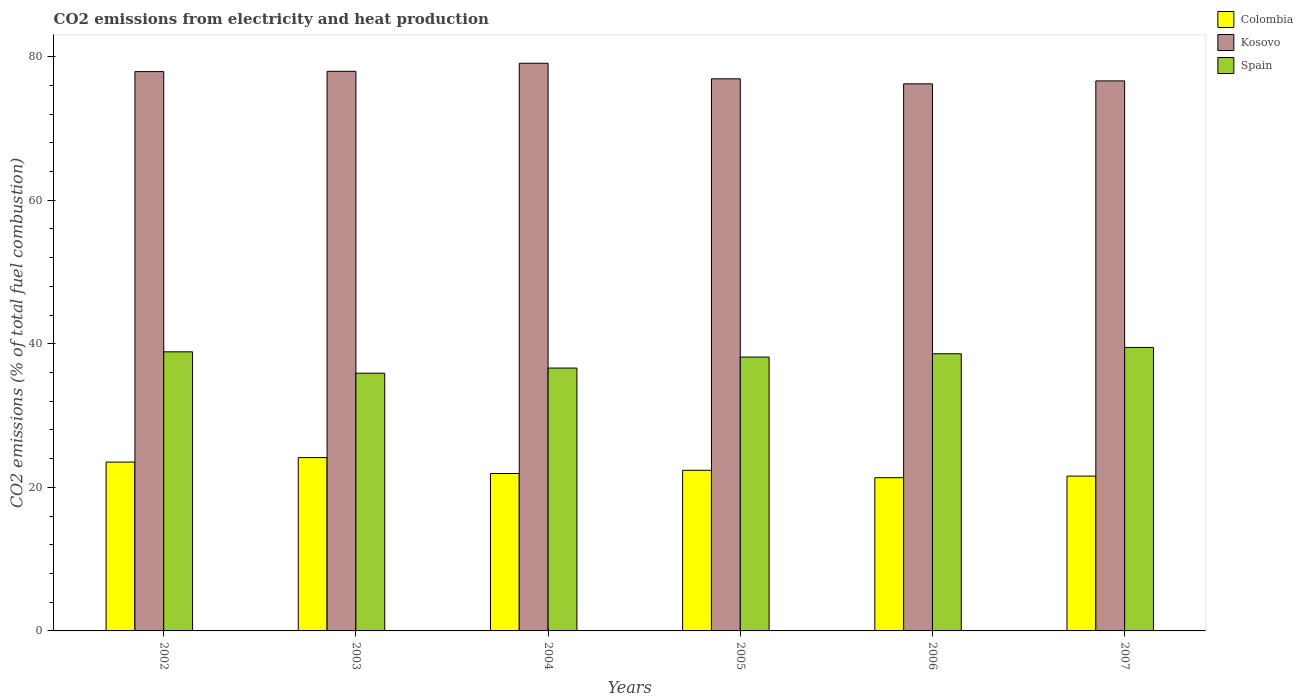Are the number of bars per tick equal to the number of legend labels?
Your answer should be very brief. Yes. Are the number of bars on each tick of the X-axis equal?
Provide a succinct answer. Yes. How many bars are there on the 6th tick from the left?
Your answer should be compact. 3. How many bars are there on the 2nd tick from the right?
Ensure brevity in your answer.  3. What is the label of the 5th group of bars from the left?
Your answer should be compact. 2006. What is the amount of CO2 emitted in Kosovo in 2002?
Make the answer very short. 77.92. Across all years, what is the maximum amount of CO2 emitted in Kosovo?
Make the answer very short. 79.08. Across all years, what is the minimum amount of CO2 emitted in Colombia?
Provide a short and direct response. 21.35. What is the total amount of CO2 emitted in Spain in the graph?
Ensure brevity in your answer.  227.66. What is the difference between the amount of CO2 emitted in Spain in 2002 and that in 2003?
Offer a terse response. 2.98. What is the difference between the amount of CO2 emitted in Spain in 2003 and the amount of CO2 emitted in Kosovo in 2005?
Your answer should be compact. -41.01. What is the average amount of CO2 emitted in Kosovo per year?
Your answer should be compact. 77.45. In the year 2006, what is the difference between the amount of CO2 emitted in Colombia and amount of CO2 emitted in Spain?
Offer a terse response. -17.27. In how many years, is the amount of CO2 emitted in Kosovo greater than 8 %?
Make the answer very short. 6. What is the ratio of the amount of CO2 emitted in Spain in 2003 to that in 2005?
Offer a very short reply. 0.94. Is the amount of CO2 emitted in Colombia in 2004 less than that in 2006?
Provide a succinct answer. No. What is the difference between the highest and the second highest amount of CO2 emitted in Colombia?
Give a very brief answer. 0.62. What is the difference between the highest and the lowest amount of CO2 emitted in Kosovo?
Make the answer very short. 2.87. In how many years, is the amount of CO2 emitted in Colombia greater than the average amount of CO2 emitted in Colombia taken over all years?
Give a very brief answer. 2. Is it the case that in every year, the sum of the amount of CO2 emitted in Kosovo and amount of CO2 emitted in Colombia is greater than the amount of CO2 emitted in Spain?
Provide a succinct answer. Yes. Are all the bars in the graph horizontal?
Give a very brief answer. No. What is the difference between two consecutive major ticks on the Y-axis?
Your response must be concise. 20. Are the values on the major ticks of Y-axis written in scientific E-notation?
Your answer should be very brief. No. Does the graph contain any zero values?
Offer a terse response. No. Does the graph contain grids?
Make the answer very short. No. How many legend labels are there?
Make the answer very short. 3. What is the title of the graph?
Ensure brevity in your answer.  CO2 emissions from electricity and heat production. Does "Luxembourg" appear as one of the legend labels in the graph?
Offer a very short reply. No. What is the label or title of the X-axis?
Provide a short and direct response. Years. What is the label or title of the Y-axis?
Your answer should be compact. CO2 emissions (% of total fuel combustion). What is the CO2 emissions (% of total fuel combustion) of Colombia in 2002?
Your answer should be very brief. 23.52. What is the CO2 emissions (% of total fuel combustion) in Kosovo in 2002?
Your answer should be compact. 77.92. What is the CO2 emissions (% of total fuel combustion) of Spain in 2002?
Keep it short and to the point. 38.88. What is the CO2 emissions (% of total fuel combustion) of Colombia in 2003?
Your response must be concise. 24.15. What is the CO2 emissions (% of total fuel combustion) in Kosovo in 2003?
Provide a short and direct response. 77.96. What is the CO2 emissions (% of total fuel combustion) in Spain in 2003?
Your response must be concise. 35.9. What is the CO2 emissions (% of total fuel combustion) of Colombia in 2004?
Your answer should be very brief. 21.92. What is the CO2 emissions (% of total fuel combustion) of Kosovo in 2004?
Provide a short and direct response. 79.08. What is the CO2 emissions (% of total fuel combustion) in Spain in 2004?
Your answer should be very brief. 36.62. What is the CO2 emissions (% of total fuel combustion) in Colombia in 2005?
Offer a terse response. 22.38. What is the CO2 emissions (% of total fuel combustion) in Kosovo in 2005?
Your response must be concise. 76.91. What is the CO2 emissions (% of total fuel combustion) of Spain in 2005?
Ensure brevity in your answer.  38.15. What is the CO2 emissions (% of total fuel combustion) in Colombia in 2006?
Provide a succinct answer. 21.35. What is the CO2 emissions (% of total fuel combustion) of Kosovo in 2006?
Give a very brief answer. 76.21. What is the CO2 emissions (% of total fuel combustion) in Spain in 2006?
Offer a very short reply. 38.61. What is the CO2 emissions (% of total fuel combustion) in Colombia in 2007?
Make the answer very short. 21.57. What is the CO2 emissions (% of total fuel combustion) in Kosovo in 2007?
Your answer should be very brief. 76.62. What is the CO2 emissions (% of total fuel combustion) in Spain in 2007?
Ensure brevity in your answer.  39.49. Across all years, what is the maximum CO2 emissions (% of total fuel combustion) in Colombia?
Ensure brevity in your answer.  24.15. Across all years, what is the maximum CO2 emissions (% of total fuel combustion) of Kosovo?
Provide a short and direct response. 79.08. Across all years, what is the maximum CO2 emissions (% of total fuel combustion) of Spain?
Give a very brief answer. 39.49. Across all years, what is the minimum CO2 emissions (% of total fuel combustion) in Colombia?
Make the answer very short. 21.35. Across all years, what is the minimum CO2 emissions (% of total fuel combustion) in Kosovo?
Offer a terse response. 76.21. Across all years, what is the minimum CO2 emissions (% of total fuel combustion) of Spain?
Your answer should be compact. 35.9. What is the total CO2 emissions (% of total fuel combustion) of Colombia in the graph?
Provide a short and direct response. 134.88. What is the total CO2 emissions (% of total fuel combustion) in Kosovo in the graph?
Give a very brief answer. 464.71. What is the total CO2 emissions (% of total fuel combustion) in Spain in the graph?
Keep it short and to the point. 227.66. What is the difference between the CO2 emissions (% of total fuel combustion) of Colombia in 2002 and that in 2003?
Your response must be concise. -0.62. What is the difference between the CO2 emissions (% of total fuel combustion) of Kosovo in 2002 and that in 2003?
Your answer should be very brief. -0.04. What is the difference between the CO2 emissions (% of total fuel combustion) of Spain in 2002 and that in 2003?
Your answer should be compact. 2.98. What is the difference between the CO2 emissions (% of total fuel combustion) of Colombia in 2002 and that in 2004?
Provide a short and direct response. 1.6. What is the difference between the CO2 emissions (% of total fuel combustion) in Kosovo in 2002 and that in 2004?
Provide a short and direct response. -1.16. What is the difference between the CO2 emissions (% of total fuel combustion) in Spain in 2002 and that in 2004?
Keep it short and to the point. 2.26. What is the difference between the CO2 emissions (% of total fuel combustion) of Colombia in 2002 and that in 2005?
Give a very brief answer. 1.15. What is the difference between the CO2 emissions (% of total fuel combustion) in Spain in 2002 and that in 2005?
Provide a short and direct response. 0.73. What is the difference between the CO2 emissions (% of total fuel combustion) in Colombia in 2002 and that in 2006?
Your answer should be compact. 2.18. What is the difference between the CO2 emissions (% of total fuel combustion) in Kosovo in 2002 and that in 2006?
Your answer should be very brief. 1.71. What is the difference between the CO2 emissions (% of total fuel combustion) of Spain in 2002 and that in 2006?
Give a very brief answer. 0.27. What is the difference between the CO2 emissions (% of total fuel combustion) of Colombia in 2002 and that in 2007?
Your answer should be very brief. 1.96. What is the difference between the CO2 emissions (% of total fuel combustion) of Kosovo in 2002 and that in 2007?
Your answer should be compact. 1.29. What is the difference between the CO2 emissions (% of total fuel combustion) in Spain in 2002 and that in 2007?
Ensure brevity in your answer.  -0.61. What is the difference between the CO2 emissions (% of total fuel combustion) in Colombia in 2003 and that in 2004?
Make the answer very short. 2.22. What is the difference between the CO2 emissions (% of total fuel combustion) of Kosovo in 2003 and that in 2004?
Make the answer very short. -1.12. What is the difference between the CO2 emissions (% of total fuel combustion) in Spain in 2003 and that in 2004?
Provide a succinct answer. -0.72. What is the difference between the CO2 emissions (% of total fuel combustion) in Colombia in 2003 and that in 2005?
Offer a very short reply. 1.77. What is the difference between the CO2 emissions (% of total fuel combustion) in Kosovo in 2003 and that in 2005?
Your answer should be very brief. 1.05. What is the difference between the CO2 emissions (% of total fuel combustion) of Spain in 2003 and that in 2005?
Ensure brevity in your answer.  -2.25. What is the difference between the CO2 emissions (% of total fuel combustion) in Colombia in 2003 and that in 2006?
Your answer should be very brief. 2.8. What is the difference between the CO2 emissions (% of total fuel combustion) in Kosovo in 2003 and that in 2006?
Provide a succinct answer. 1.75. What is the difference between the CO2 emissions (% of total fuel combustion) of Spain in 2003 and that in 2006?
Ensure brevity in your answer.  -2.71. What is the difference between the CO2 emissions (% of total fuel combustion) of Colombia in 2003 and that in 2007?
Your response must be concise. 2.58. What is the difference between the CO2 emissions (% of total fuel combustion) of Kosovo in 2003 and that in 2007?
Make the answer very short. 1.34. What is the difference between the CO2 emissions (% of total fuel combustion) of Spain in 2003 and that in 2007?
Ensure brevity in your answer.  -3.59. What is the difference between the CO2 emissions (% of total fuel combustion) of Colombia in 2004 and that in 2005?
Offer a very short reply. -0.45. What is the difference between the CO2 emissions (% of total fuel combustion) of Kosovo in 2004 and that in 2005?
Ensure brevity in your answer.  2.17. What is the difference between the CO2 emissions (% of total fuel combustion) of Spain in 2004 and that in 2005?
Provide a short and direct response. -1.53. What is the difference between the CO2 emissions (% of total fuel combustion) of Colombia in 2004 and that in 2006?
Your answer should be very brief. 0.58. What is the difference between the CO2 emissions (% of total fuel combustion) in Kosovo in 2004 and that in 2006?
Your answer should be compact. 2.87. What is the difference between the CO2 emissions (% of total fuel combustion) in Spain in 2004 and that in 2006?
Make the answer very short. -1.99. What is the difference between the CO2 emissions (% of total fuel combustion) in Colombia in 2004 and that in 2007?
Keep it short and to the point. 0.36. What is the difference between the CO2 emissions (% of total fuel combustion) in Kosovo in 2004 and that in 2007?
Offer a terse response. 2.46. What is the difference between the CO2 emissions (% of total fuel combustion) of Spain in 2004 and that in 2007?
Keep it short and to the point. -2.87. What is the difference between the CO2 emissions (% of total fuel combustion) of Colombia in 2005 and that in 2006?
Provide a succinct answer. 1.03. What is the difference between the CO2 emissions (% of total fuel combustion) of Kosovo in 2005 and that in 2006?
Keep it short and to the point. 0.7. What is the difference between the CO2 emissions (% of total fuel combustion) in Spain in 2005 and that in 2006?
Make the answer very short. -0.46. What is the difference between the CO2 emissions (% of total fuel combustion) of Colombia in 2005 and that in 2007?
Provide a short and direct response. 0.81. What is the difference between the CO2 emissions (% of total fuel combustion) of Kosovo in 2005 and that in 2007?
Your answer should be very brief. 0.29. What is the difference between the CO2 emissions (% of total fuel combustion) of Spain in 2005 and that in 2007?
Give a very brief answer. -1.34. What is the difference between the CO2 emissions (% of total fuel combustion) in Colombia in 2006 and that in 2007?
Your answer should be compact. -0.22. What is the difference between the CO2 emissions (% of total fuel combustion) of Kosovo in 2006 and that in 2007?
Provide a short and direct response. -0.41. What is the difference between the CO2 emissions (% of total fuel combustion) of Spain in 2006 and that in 2007?
Provide a short and direct response. -0.88. What is the difference between the CO2 emissions (% of total fuel combustion) of Colombia in 2002 and the CO2 emissions (% of total fuel combustion) of Kosovo in 2003?
Your answer should be compact. -54.44. What is the difference between the CO2 emissions (% of total fuel combustion) of Colombia in 2002 and the CO2 emissions (% of total fuel combustion) of Spain in 2003?
Make the answer very short. -12.38. What is the difference between the CO2 emissions (% of total fuel combustion) in Kosovo in 2002 and the CO2 emissions (% of total fuel combustion) in Spain in 2003?
Give a very brief answer. 42.02. What is the difference between the CO2 emissions (% of total fuel combustion) of Colombia in 2002 and the CO2 emissions (% of total fuel combustion) of Kosovo in 2004?
Keep it short and to the point. -55.56. What is the difference between the CO2 emissions (% of total fuel combustion) of Colombia in 2002 and the CO2 emissions (% of total fuel combustion) of Spain in 2004?
Keep it short and to the point. -13.1. What is the difference between the CO2 emissions (% of total fuel combustion) of Kosovo in 2002 and the CO2 emissions (% of total fuel combustion) of Spain in 2004?
Provide a short and direct response. 41.3. What is the difference between the CO2 emissions (% of total fuel combustion) in Colombia in 2002 and the CO2 emissions (% of total fuel combustion) in Kosovo in 2005?
Ensure brevity in your answer.  -53.39. What is the difference between the CO2 emissions (% of total fuel combustion) in Colombia in 2002 and the CO2 emissions (% of total fuel combustion) in Spain in 2005?
Provide a short and direct response. -14.63. What is the difference between the CO2 emissions (% of total fuel combustion) in Kosovo in 2002 and the CO2 emissions (% of total fuel combustion) in Spain in 2005?
Your response must be concise. 39.77. What is the difference between the CO2 emissions (% of total fuel combustion) in Colombia in 2002 and the CO2 emissions (% of total fuel combustion) in Kosovo in 2006?
Provide a short and direct response. -52.69. What is the difference between the CO2 emissions (% of total fuel combustion) in Colombia in 2002 and the CO2 emissions (% of total fuel combustion) in Spain in 2006?
Provide a succinct answer. -15.09. What is the difference between the CO2 emissions (% of total fuel combustion) in Kosovo in 2002 and the CO2 emissions (% of total fuel combustion) in Spain in 2006?
Your answer should be very brief. 39.31. What is the difference between the CO2 emissions (% of total fuel combustion) in Colombia in 2002 and the CO2 emissions (% of total fuel combustion) in Kosovo in 2007?
Your answer should be compact. -53.1. What is the difference between the CO2 emissions (% of total fuel combustion) of Colombia in 2002 and the CO2 emissions (% of total fuel combustion) of Spain in 2007?
Make the answer very short. -15.97. What is the difference between the CO2 emissions (% of total fuel combustion) of Kosovo in 2002 and the CO2 emissions (% of total fuel combustion) of Spain in 2007?
Offer a very short reply. 38.43. What is the difference between the CO2 emissions (% of total fuel combustion) in Colombia in 2003 and the CO2 emissions (% of total fuel combustion) in Kosovo in 2004?
Your answer should be compact. -54.93. What is the difference between the CO2 emissions (% of total fuel combustion) of Colombia in 2003 and the CO2 emissions (% of total fuel combustion) of Spain in 2004?
Keep it short and to the point. -12.47. What is the difference between the CO2 emissions (% of total fuel combustion) of Kosovo in 2003 and the CO2 emissions (% of total fuel combustion) of Spain in 2004?
Make the answer very short. 41.34. What is the difference between the CO2 emissions (% of total fuel combustion) of Colombia in 2003 and the CO2 emissions (% of total fuel combustion) of Kosovo in 2005?
Your answer should be very brief. -52.76. What is the difference between the CO2 emissions (% of total fuel combustion) of Colombia in 2003 and the CO2 emissions (% of total fuel combustion) of Spain in 2005?
Ensure brevity in your answer.  -14.01. What is the difference between the CO2 emissions (% of total fuel combustion) of Kosovo in 2003 and the CO2 emissions (% of total fuel combustion) of Spain in 2005?
Your answer should be very brief. 39.81. What is the difference between the CO2 emissions (% of total fuel combustion) in Colombia in 2003 and the CO2 emissions (% of total fuel combustion) in Kosovo in 2006?
Your answer should be very brief. -52.07. What is the difference between the CO2 emissions (% of total fuel combustion) in Colombia in 2003 and the CO2 emissions (% of total fuel combustion) in Spain in 2006?
Offer a very short reply. -14.46. What is the difference between the CO2 emissions (% of total fuel combustion) in Kosovo in 2003 and the CO2 emissions (% of total fuel combustion) in Spain in 2006?
Ensure brevity in your answer.  39.35. What is the difference between the CO2 emissions (% of total fuel combustion) in Colombia in 2003 and the CO2 emissions (% of total fuel combustion) in Kosovo in 2007?
Provide a short and direct response. -52.48. What is the difference between the CO2 emissions (% of total fuel combustion) in Colombia in 2003 and the CO2 emissions (% of total fuel combustion) in Spain in 2007?
Ensure brevity in your answer.  -15.35. What is the difference between the CO2 emissions (% of total fuel combustion) of Kosovo in 2003 and the CO2 emissions (% of total fuel combustion) of Spain in 2007?
Your response must be concise. 38.47. What is the difference between the CO2 emissions (% of total fuel combustion) of Colombia in 2004 and the CO2 emissions (% of total fuel combustion) of Kosovo in 2005?
Offer a very short reply. -54.99. What is the difference between the CO2 emissions (% of total fuel combustion) in Colombia in 2004 and the CO2 emissions (% of total fuel combustion) in Spain in 2005?
Give a very brief answer. -16.23. What is the difference between the CO2 emissions (% of total fuel combustion) of Kosovo in 2004 and the CO2 emissions (% of total fuel combustion) of Spain in 2005?
Offer a very short reply. 40.93. What is the difference between the CO2 emissions (% of total fuel combustion) of Colombia in 2004 and the CO2 emissions (% of total fuel combustion) of Kosovo in 2006?
Your response must be concise. -54.29. What is the difference between the CO2 emissions (% of total fuel combustion) of Colombia in 2004 and the CO2 emissions (% of total fuel combustion) of Spain in 2006?
Ensure brevity in your answer.  -16.69. What is the difference between the CO2 emissions (% of total fuel combustion) in Kosovo in 2004 and the CO2 emissions (% of total fuel combustion) in Spain in 2006?
Ensure brevity in your answer.  40.47. What is the difference between the CO2 emissions (% of total fuel combustion) of Colombia in 2004 and the CO2 emissions (% of total fuel combustion) of Kosovo in 2007?
Your answer should be compact. -54.7. What is the difference between the CO2 emissions (% of total fuel combustion) in Colombia in 2004 and the CO2 emissions (% of total fuel combustion) in Spain in 2007?
Make the answer very short. -17.57. What is the difference between the CO2 emissions (% of total fuel combustion) of Kosovo in 2004 and the CO2 emissions (% of total fuel combustion) of Spain in 2007?
Provide a short and direct response. 39.59. What is the difference between the CO2 emissions (% of total fuel combustion) in Colombia in 2005 and the CO2 emissions (% of total fuel combustion) in Kosovo in 2006?
Provide a succinct answer. -53.83. What is the difference between the CO2 emissions (% of total fuel combustion) in Colombia in 2005 and the CO2 emissions (% of total fuel combustion) in Spain in 2006?
Offer a very short reply. -16.23. What is the difference between the CO2 emissions (% of total fuel combustion) of Kosovo in 2005 and the CO2 emissions (% of total fuel combustion) of Spain in 2006?
Your response must be concise. 38.3. What is the difference between the CO2 emissions (% of total fuel combustion) of Colombia in 2005 and the CO2 emissions (% of total fuel combustion) of Kosovo in 2007?
Provide a short and direct response. -54.25. What is the difference between the CO2 emissions (% of total fuel combustion) of Colombia in 2005 and the CO2 emissions (% of total fuel combustion) of Spain in 2007?
Provide a succinct answer. -17.12. What is the difference between the CO2 emissions (% of total fuel combustion) in Kosovo in 2005 and the CO2 emissions (% of total fuel combustion) in Spain in 2007?
Your answer should be compact. 37.42. What is the difference between the CO2 emissions (% of total fuel combustion) in Colombia in 2006 and the CO2 emissions (% of total fuel combustion) in Kosovo in 2007?
Offer a terse response. -55.28. What is the difference between the CO2 emissions (% of total fuel combustion) in Colombia in 2006 and the CO2 emissions (% of total fuel combustion) in Spain in 2007?
Offer a very short reply. -18.15. What is the difference between the CO2 emissions (% of total fuel combustion) in Kosovo in 2006 and the CO2 emissions (% of total fuel combustion) in Spain in 2007?
Provide a short and direct response. 36.72. What is the average CO2 emissions (% of total fuel combustion) of Colombia per year?
Make the answer very short. 22.48. What is the average CO2 emissions (% of total fuel combustion) in Kosovo per year?
Offer a very short reply. 77.45. What is the average CO2 emissions (% of total fuel combustion) in Spain per year?
Offer a terse response. 37.94. In the year 2002, what is the difference between the CO2 emissions (% of total fuel combustion) of Colombia and CO2 emissions (% of total fuel combustion) of Kosovo?
Your response must be concise. -54.39. In the year 2002, what is the difference between the CO2 emissions (% of total fuel combustion) in Colombia and CO2 emissions (% of total fuel combustion) in Spain?
Provide a short and direct response. -15.36. In the year 2002, what is the difference between the CO2 emissions (% of total fuel combustion) in Kosovo and CO2 emissions (% of total fuel combustion) in Spain?
Ensure brevity in your answer.  39.04. In the year 2003, what is the difference between the CO2 emissions (% of total fuel combustion) in Colombia and CO2 emissions (% of total fuel combustion) in Kosovo?
Ensure brevity in your answer.  -53.81. In the year 2003, what is the difference between the CO2 emissions (% of total fuel combustion) in Colombia and CO2 emissions (% of total fuel combustion) in Spain?
Provide a short and direct response. -11.75. In the year 2003, what is the difference between the CO2 emissions (% of total fuel combustion) in Kosovo and CO2 emissions (% of total fuel combustion) in Spain?
Ensure brevity in your answer.  42.06. In the year 2004, what is the difference between the CO2 emissions (% of total fuel combustion) of Colombia and CO2 emissions (% of total fuel combustion) of Kosovo?
Provide a short and direct response. -57.16. In the year 2004, what is the difference between the CO2 emissions (% of total fuel combustion) of Colombia and CO2 emissions (% of total fuel combustion) of Spain?
Provide a succinct answer. -14.69. In the year 2004, what is the difference between the CO2 emissions (% of total fuel combustion) in Kosovo and CO2 emissions (% of total fuel combustion) in Spain?
Provide a short and direct response. 42.46. In the year 2005, what is the difference between the CO2 emissions (% of total fuel combustion) in Colombia and CO2 emissions (% of total fuel combustion) in Kosovo?
Offer a very short reply. -54.53. In the year 2005, what is the difference between the CO2 emissions (% of total fuel combustion) in Colombia and CO2 emissions (% of total fuel combustion) in Spain?
Your answer should be very brief. -15.78. In the year 2005, what is the difference between the CO2 emissions (% of total fuel combustion) of Kosovo and CO2 emissions (% of total fuel combustion) of Spain?
Provide a succinct answer. 38.76. In the year 2006, what is the difference between the CO2 emissions (% of total fuel combustion) in Colombia and CO2 emissions (% of total fuel combustion) in Kosovo?
Ensure brevity in your answer.  -54.87. In the year 2006, what is the difference between the CO2 emissions (% of total fuel combustion) of Colombia and CO2 emissions (% of total fuel combustion) of Spain?
Your response must be concise. -17.27. In the year 2006, what is the difference between the CO2 emissions (% of total fuel combustion) in Kosovo and CO2 emissions (% of total fuel combustion) in Spain?
Give a very brief answer. 37.6. In the year 2007, what is the difference between the CO2 emissions (% of total fuel combustion) of Colombia and CO2 emissions (% of total fuel combustion) of Kosovo?
Your answer should be compact. -55.06. In the year 2007, what is the difference between the CO2 emissions (% of total fuel combustion) in Colombia and CO2 emissions (% of total fuel combustion) in Spain?
Offer a very short reply. -17.92. In the year 2007, what is the difference between the CO2 emissions (% of total fuel combustion) in Kosovo and CO2 emissions (% of total fuel combustion) in Spain?
Your answer should be very brief. 37.13. What is the ratio of the CO2 emissions (% of total fuel combustion) of Colombia in 2002 to that in 2003?
Keep it short and to the point. 0.97. What is the ratio of the CO2 emissions (% of total fuel combustion) in Spain in 2002 to that in 2003?
Offer a terse response. 1.08. What is the ratio of the CO2 emissions (% of total fuel combustion) of Colombia in 2002 to that in 2004?
Make the answer very short. 1.07. What is the ratio of the CO2 emissions (% of total fuel combustion) of Kosovo in 2002 to that in 2004?
Your response must be concise. 0.99. What is the ratio of the CO2 emissions (% of total fuel combustion) of Spain in 2002 to that in 2004?
Offer a very short reply. 1.06. What is the ratio of the CO2 emissions (% of total fuel combustion) in Colombia in 2002 to that in 2005?
Offer a very short reply. 1.05. What is the ratio of the CO2 emissions (% of total fuel combustion) in Kosovo in 2002 to that in 2005?
Ensure brevity in your answer.  1.01. What is the ratio of the CO2 emissions (% of total fuel combustion) of Spain in 2002 to that in 2005?
Make the answer very short. 1.02. What is the ratio of the CO2 emissions (% of total fuel combustion) in Colombia in 2002 to that in 2006?
Offer a terse response. 1.1. What is the ratio of the CO2 emissions (% of total fuel combustion) of Kosovo in 2002 to that in 2006?
Your answer should be very brief. 1.02. What is the ratio of the CO2 emissions (% of total fuel combustion) in Spain in 2002 to that in 2006?
Offer a terse response. 1.01. What is the ratio of the CO2 emissions (% of total fuel combustion) in Colombia in 2002 to that in 2007?
Your answer should be compact. 1.09. What is the ratio of the CO2 emissions (% of total fuel combustion) in Kosovo in 2002 to that in 2007?
Your answer should be very brief. 1.02. What is the ratio of the CO2 emissions (% of total fuel combustion) of Spain in 2002 to that in 2007?
Offer a very short reply. 0.98. What is the ratio of the CO2 emissions (% of total fuel combustion) in Colombia in 2003 to that in 2004?
Your response must be concise. 1.1. What is the ratio of the CO2 emissions (% of total fuel combustion) in Kosovo in 2003 to that in 2004?
Your answer should be compact. 0.99. What is the ratio of the CO2 emissions (% of total fuel combustion) of Spain in 2003 to that in 2004?
Provide a short and direct response. 0.98. What is the ratio of the CO2 emissions (% of total fuel combustion) in Colombia in 2003 to that in 2005?
Your response must be concise. 1.08. What is the ratio of the CO2 emissions (% of total fuel combustion) of Kosovo in 2003 to that in 2005?
Offer a very short reply. 1.01. What is the ratio of the CO2 emissions (% of total fuel combustion) in Spain in 2003 to that in 2005?
Your answer should be compact. 0.94. What is the ratio of the CO2 emissions (% of total fuel combustion) of Colombia in 2003 to that in 2006?
Your answer should be very brief. 1.13. What is the ratio of the CO2 emissions (% of total fuel combustion) in Kosovo in 2003 to that in 2006?
Keep it short and to the point. 1.02. What is the ratio of the CO2 emissions (% of total fuel combustion) of Spain in 2003 to that in 2006?
Keep it short and to the point. 0.93. What is the ratio of the CO2 emissions (% of total fuel combustion) in Colombia in 2003 to that in 2007?
Your response must be concise. 1.12. What is the ratio of the CO2 emissions (% of total fuel combustion) in Kosovo in 2003 to that in 2007?
Provide a succinct answer. 1.02. What is the ratio of the CO2 emissions (% of total fuel combustion) of Spain in 2003 to that in 2007?
Ensure brevity in your answer.  0.91. What is the ratio of the CO2 emissions (% of total fuel combustion) in Colombia in 2004 to that in 2005?
Keep it short and to the point. 0.98. What is the ratio of the CO2 emissions (% of total fuel combustion) in Kosovo in 2004 to that in 2005?
Provide a short and direct response. 1.03. What is the ratio of the CO2 emissions (% of total fuel combustion) of Spain in 2004 to that in 2005?
Offer a terse response. 0.96. What is the ratio of the CO2 emissions (% of total fuel combustion) of Colombia in 2004 to that in 2006?
Provide a succinct answer. 1.03. What is the ratio of the CO2 emissions (% of total fuel combustion) in Kosovo in 2004 to that in 2006?
Your answer should be very brief. 1.04. What is the ratio of the CO2 emissions (% of total fuel combustion) in Spain in 2004 to that in 2006?
Your response must be concise. 0.95. What is the ratio of the CO2 emissions (% of total fuel combustion) of Colombia in 2004 to that in 2007?
Keep it short and to the point. 1.02. What is the ratio of the CO2 emissions (% of total fuel combustion) of Kosovo in 2004 to that in 2007?
Make the answer very short. 1.03. What is the ratio of the CO2 emissions (% of total fuel combustion) of Spain in 2004 to that in 2007?
Keep it short and to the point. 0.93. What is the ratio of the CO2 emissions (% of total fuel combustion) of Colombia in 2005 to that in 2006?
Offer a terse response. 1.05. What is the ratio of the CO2 emissions (% of total fuel combustion) in Kosovo in 2005 to that in 2006?
Provide a succinct answer. 1.01. What is the ratio of the CO2 emissions (% of total fuel combustion) of Colombia in 2005 to that in 2007?
Provide a succinct answer. 1.04. What is the ratio of the CO2 emissions (% of total fuel combustion) of Spain in 2005 to that in 2007?
Make the answer very short. 0.97. What is the ratio of the CO2 emissions (% of total fuel combustion) of Spain in 2006 to that in 2007?
Keep it short and to the point. 0.98. What is the difference between the highest and the second highest CO2 emissions (% of total fuel combustion) in Colombia?
Provide a short and direct response. 0.62. What is the difference between the highest and the second highest CO2 emissions (% of total fuel combustion) of Kosovo?
Ensure brevity in your answer.  1.12. What is the difference between the highest and the second highest CO2 emissions (% of total fuel combustion) in Spain?
Make the answer very short. 0.61. What is the difference between the highest and the lowest CO2 emissions (% of total fuel combustion) in Colombia?
Provide a short and direct response. 2.8. What is the difference between the highest and the lowest CO2 emissions (% of total fuel combustion) of Kosovo?
Ensure brevity in your answer.  2.87. What is the difference between the highest and the lowest CO2 emissions (% of total fuel combustion) of Spain?
Offer a terse response. 3.59. 